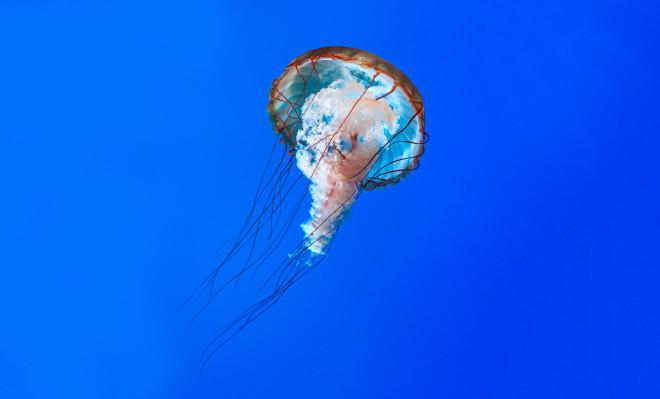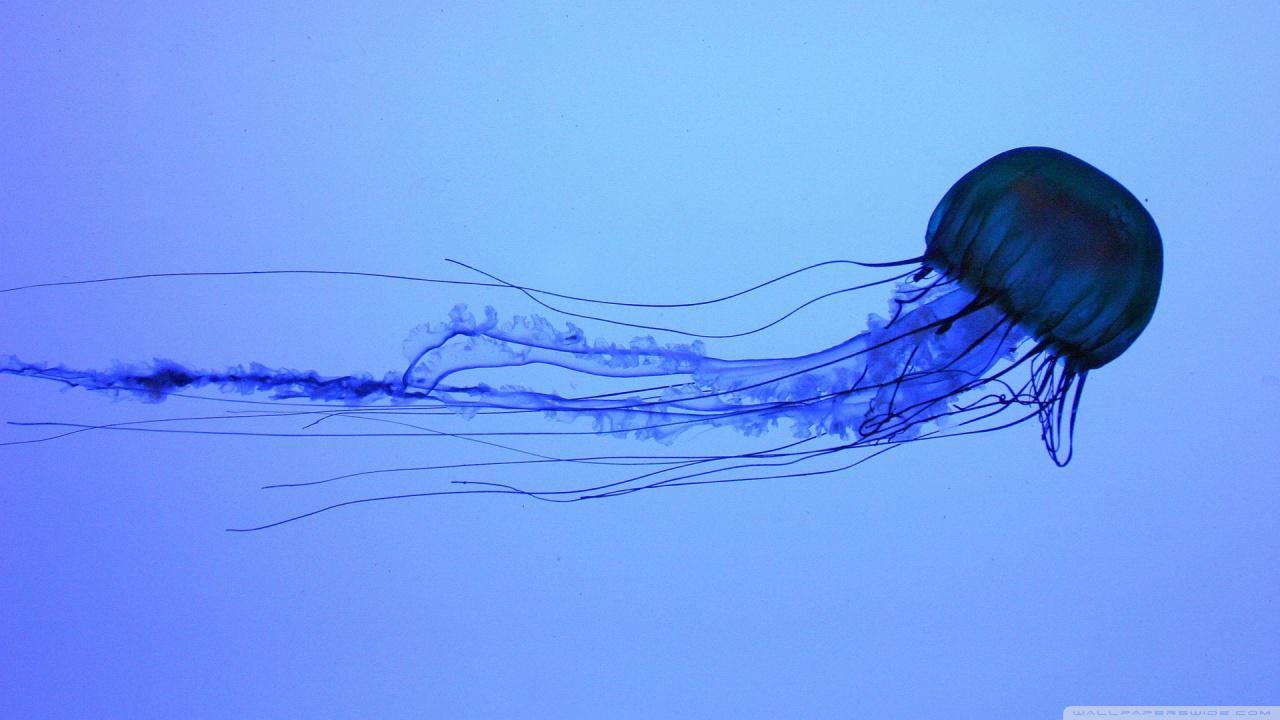The first image is the image on the left, the second image is the image on the right. Analyze the images presented: Is the assertion "Several jellyfish are swimming in the water in the image on the left." valid? Answer yes or no. No. The first image is the image on the left, the second image is the image on the right. Evaluate the accuracy of this statement regarding the images: "An image contains one prominet jellyfish, which has reddish orange """"cap"""" and string-like red tendrils trailing downward.". Is it true? Answer yes or no. Yes. 